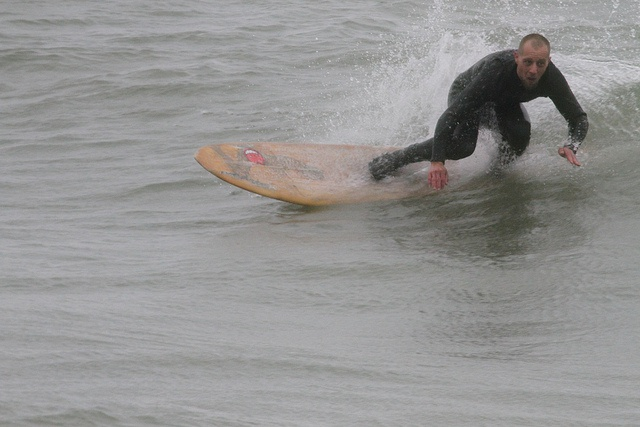Describe the objects in this image and their specific colors. I can see people in darkgray, black, and gray tones and surfboard in darkgray, tan, and gray tones in this image. 